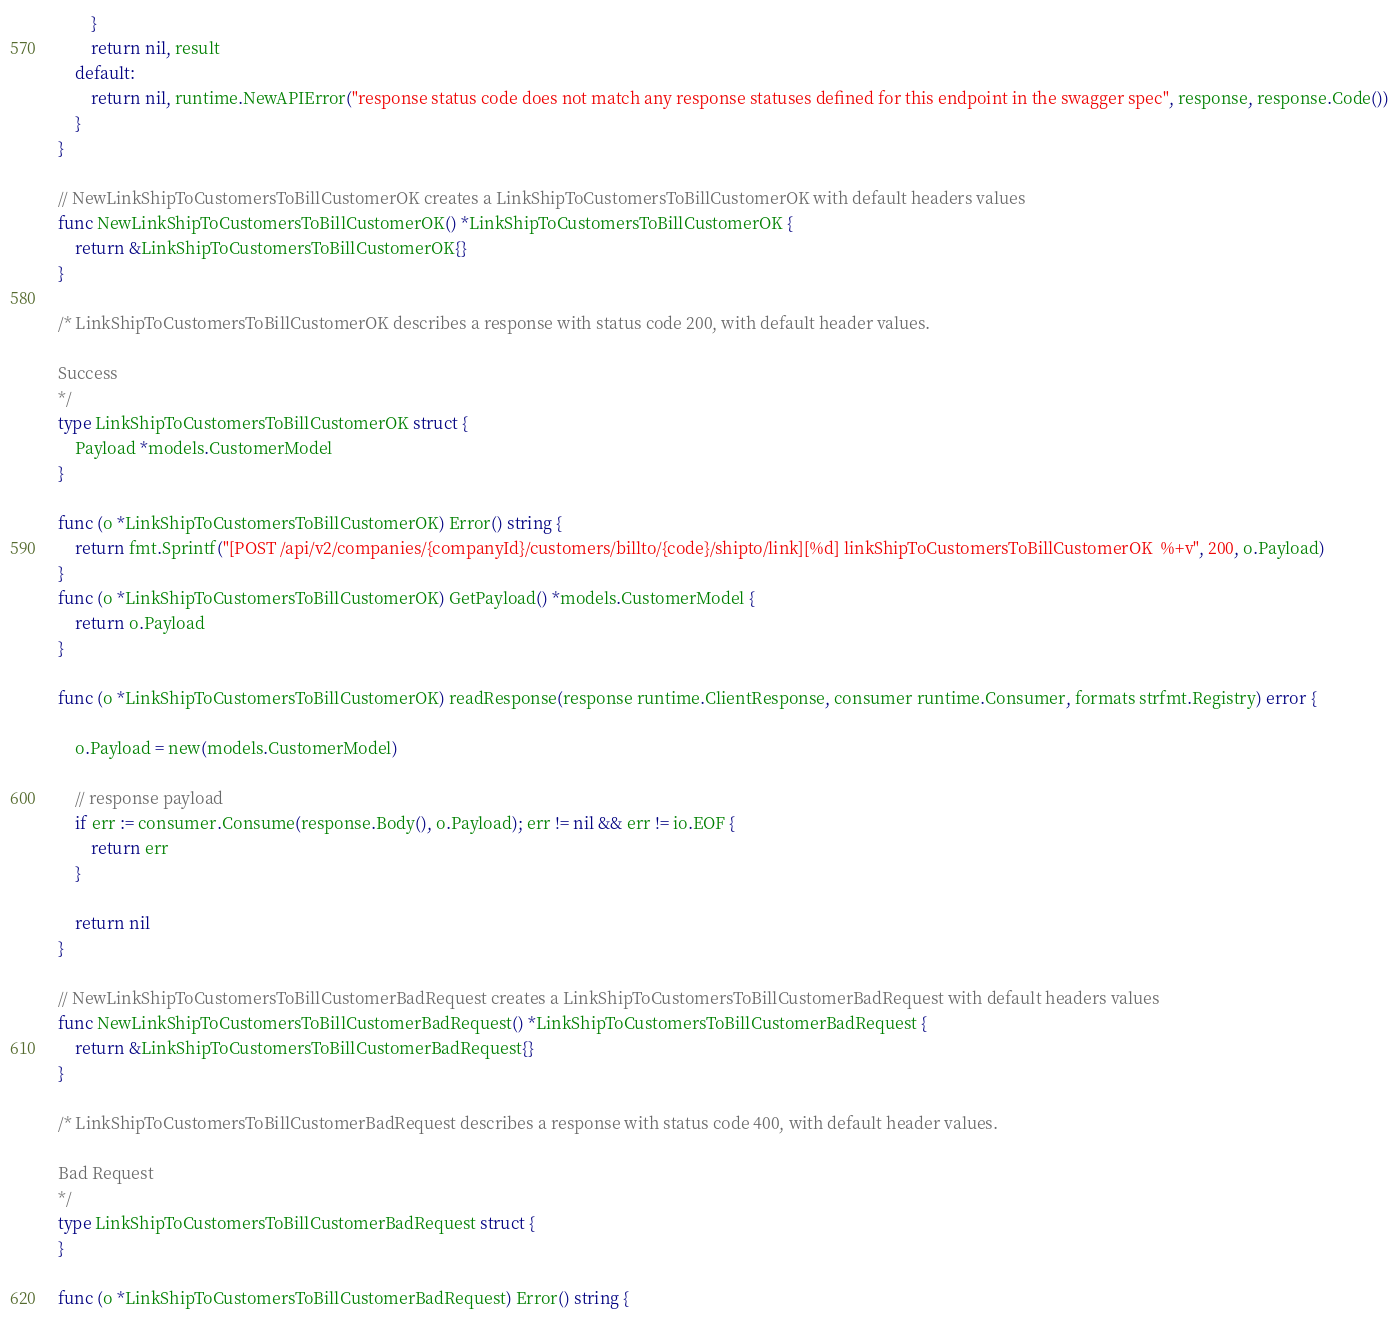Convert code to text. <code><loc_0><loc_0><loc_500><loc_500><_Go_>		}
		return nil, result
	default:
		return nil, runtime.NewAPIError("response status code does not match any response statuses defined for this endpoint in the swagger spec", response, response.Code())
	}
}

// NewLinkShipToCustomersToBillCustomerOK creates a LinkShipToCustomersToBillCustomerOK with default headers values
func NewLinkShipToCustomersToBillCustomerOK() *LinkShipToCustomersToBillCustomerOK {
	return &LinkShipToCustomersToBillCustomerOK{}
}

/* LinkShipToCustomersToBillCustomerOK describes a response with status code 200, with default header values.

Success
*/
type LinkShipToCustomersToBillCustomerOK struct {
	Payload *models.CustomerModel
}

func (o *LinkShipToCustomersToBillCustomerOK) Error() string {
	return fmt.Sprintf("[POST /api/v2/companies/{companyId}/customers/billto/{code}/shipto/link][%d] linkShipToCustomersToBillCustomerOK  %+v", 200, o.Payload)
}
func (o *LinkShipToCustomersToBillCustomerOK) GetPayload() *models.CustomerModel {
	return o.Payload
}

func (o *LinkShipToCustomersToBillCustomerOK) readResponse(response runtime.ClientResponse, consumer runtime.Consumer, formats strfmt.Registry) error {

	o.Payload = new(models.CustomerModel)

	// response payload
	if err := consumer.Consume(response.Body(), o.Payload); err != nil && err != io.EOF {
		return err
	}

	return nil
}

// NewLinkShipToCustomersToBillCustomerBadRequest creates a LinkShipToCustomersToBillCustomerBadRequest with default headers values
func NewLinkShipToCustomersToBillCustomerBadRequest() *LinkShipToCustomersToBillCustomerBadRequest {
	return &LinkShipToCustomersToBillCustomerBadRequest{}
}

/* LinkShipToCustomersToBillCustomerBadRequest describes a response with status code 400, with default header values.

Bad Request
*/
type LinkShipToCustomersToBillCustomerBadRequest struct {
}

func (o *LinkShipToCustomersToBillCustomerBadRequest) Error() string {</code> 